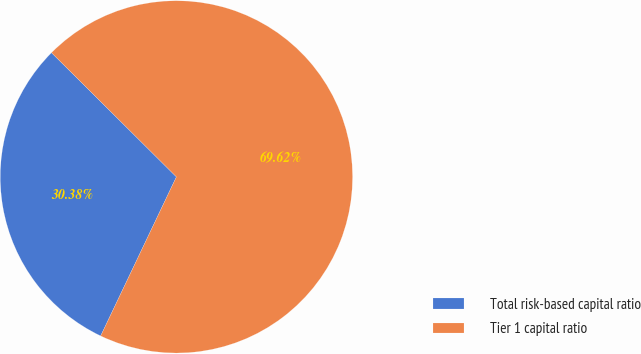<chart> <loc_0><loc_0><loc_500><loc_500><pie_chart><fcel>Total risk-based capital ratio<fcel>Tier 1 capital ratio<nl><fcel>30.38%<fcel>69.62%<nl></chart> 